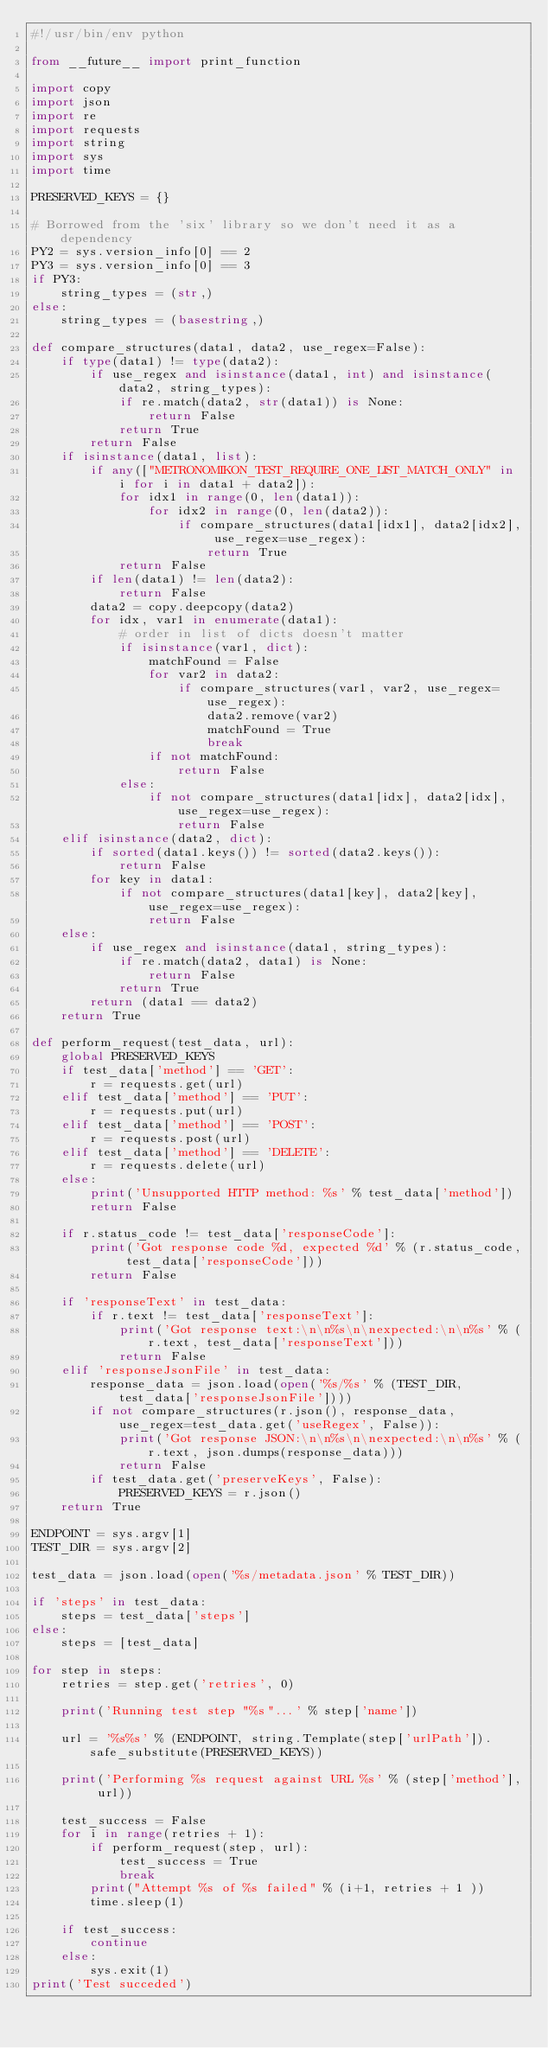<code> <loc_0><loc_0><loc_500><loc_500><_Python_>#!/usr/bin/env python

from __future__ import print_function

import copy
import json
import re
import requests
import string
import sys
import time

PRESERVED_KEYS = {}

# Borrowed from the 'six' library so we don't need it as a dependency
PY2 = sys.version_info[0] == 2
PY3 = sys.version_info[0] == 3
if PY3:
    string_types = (str,)
else:
    string_types = (basestring,)

def compare_structures(data1, data2, use_regex=False):
    if type(data1) != type(data2):
        if use_regex and isinstance(data1, int) and isinstance(data2, string_types):
            if re.match(data2, str(data1)) is None:
                return False
            return True
        return False
    if isinstance(data1, list):
        if any(["METRONOMIKON_TEST_REQUIRE_ONE_LIST_MATCH_ONLY" in i for i in data1 + data2]):
            for idx1 in range(0, len(data1)):
                for idx2 in range(0, len(data2)):
                    if compare_structures(data1[idx1], data2[idx2], use_regex=use_regex):
                        return True
            return False
        if len(data1) != len(data2):
            return False
        data2 = copy.deepcopy(data2)
        for idx, var1 in enumerate(data1):
            # order in list of dicts doesn't matter
            if isinstance(var1, dict):
                matchFound = False
                for var2 in data2:
                    if compare_structures(var1, var2, use_regex=use_regex):
                        data2.remove(var2)
                        matchFound = True
                        break
                if not matchFound:
                    return False
            else:
                if not compare_structures(data1[idx], data2[idx], use_regex=use_regex):
                    return False
    elif isinstance(data2, dict):
        if sorted(data1.keys()) != sorted(data2.keys()):
            return False
        for key in data1:
            if not compare_structures(data1[key], data2[key], use_regex=use_regex):
                return False
    else:
        if use_regex and isinstance(data1, string_types):
            if re.match(data2, data1) is None:
                return False
            return True
        return (data1 == data2)
    return True

def perform_request(test_data, url):
    global PRESERVED_KEYS
    if test_data['method'] == 'GET':
        r = requests.get(url)
    elif test_data['method'] == 'PUT':
        r = requests.put(url)
    elif test_data['method'] == 'POST':
        r = requests.post(url)
    elif test_data['method'] == 'DELETE':
        r = requests.delete(url)
    else:
        print('Unsupported HTTP method: %s' % test_data['method'])
        return False

    if r.status_code != test_data['responseCode']:
        print('Got response code %d, expected %d' % (r.status_code, test_data['responseCode']))
        return False

    if 'responseText' in test_data:
        if r.text != test_data['responseText']:
            print('Got response text:\n\n%s\n\nexpected:\n\n%s' % (r.text, test_data['responseText']))
            return False
    elif 'responseJsonFile' in test_data:
        response_data = json.load(open('%s/%s' % (TEST_DIR, test_data['responseJsonFile'])))
        if not compare_structures(r.json(), response_data, use_regex=test_data.get('useRegex', False)):
            print('Got response JSON:\n\n%s\n\nexpected:\n\n%s' % (r.text, json.dumps(response_data)))
            return False
        if test_data.get('preserveKeys', False):
            PRESERVED_KEYS = r.json()
    return True

ENDPOINT = sys.argv[1]
TEST_DIR = sys.argv[2]

test_data = json.load(open('%s/metadata.json' % TEST_DIR))

if 'steps' in test_data:
    steps = test_data['steps']
else:
    steps = [test_data]

for step in steps:
    retries = step.get('retries', 0)

    print('Running test step "%s"...' % step['name'])

    url = '%s%s' % (ENDPOINT, string.Template(step['urlPath']).safe_substitute(PRESERVED_KEYS))

    print('Performing %s request against URL %s' % (step['method'], url))

    test_success = False
    for i in range(retries + 1):
        if perform_request(step, url):
            test_success = True
            break
        print("Attempt %s of %s failed" % (i+1, retries + 1 ))
        time.sleep(1)

    if test_success:
        continue
    else:
        sys.exit(1)
print('Test succeded')
</code> 